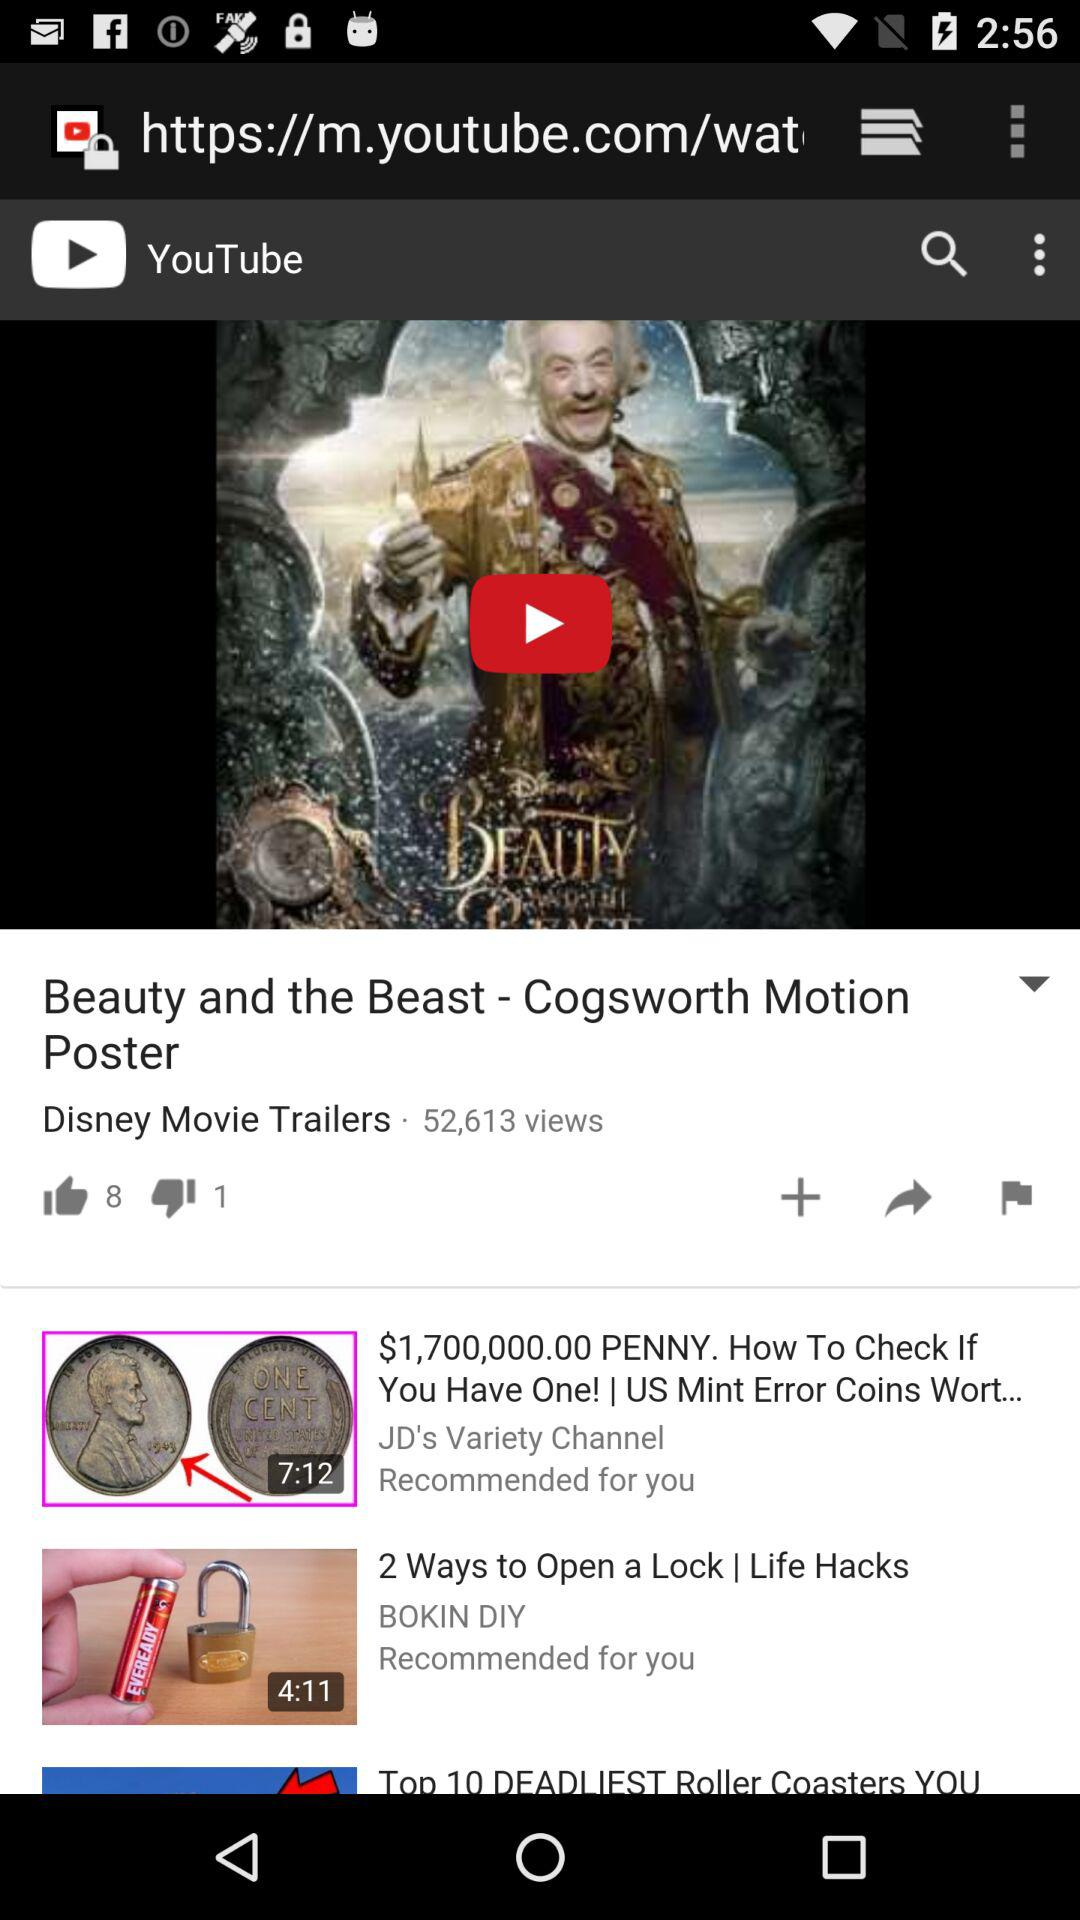How many people have liked the "Beauty and the Beast" video? There are 8 people who have liked the "Beauty and the Beast" video. 